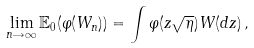Convert formula to latex. <formula><loc_0><loc_0><loc_500><loc_500>\lim _ { n \rightarrow \infty } { \mathbb { E } } _ { 0 } ( \varphi ( W _ { n } ) ) = \int \varphi ( z \sqrt { \eta } ) W ( d z ) \, ,</formula> 